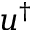<formula> <loc_0><loc_0><loc_500><loc_500>u ^ { \dagger }</formula> 